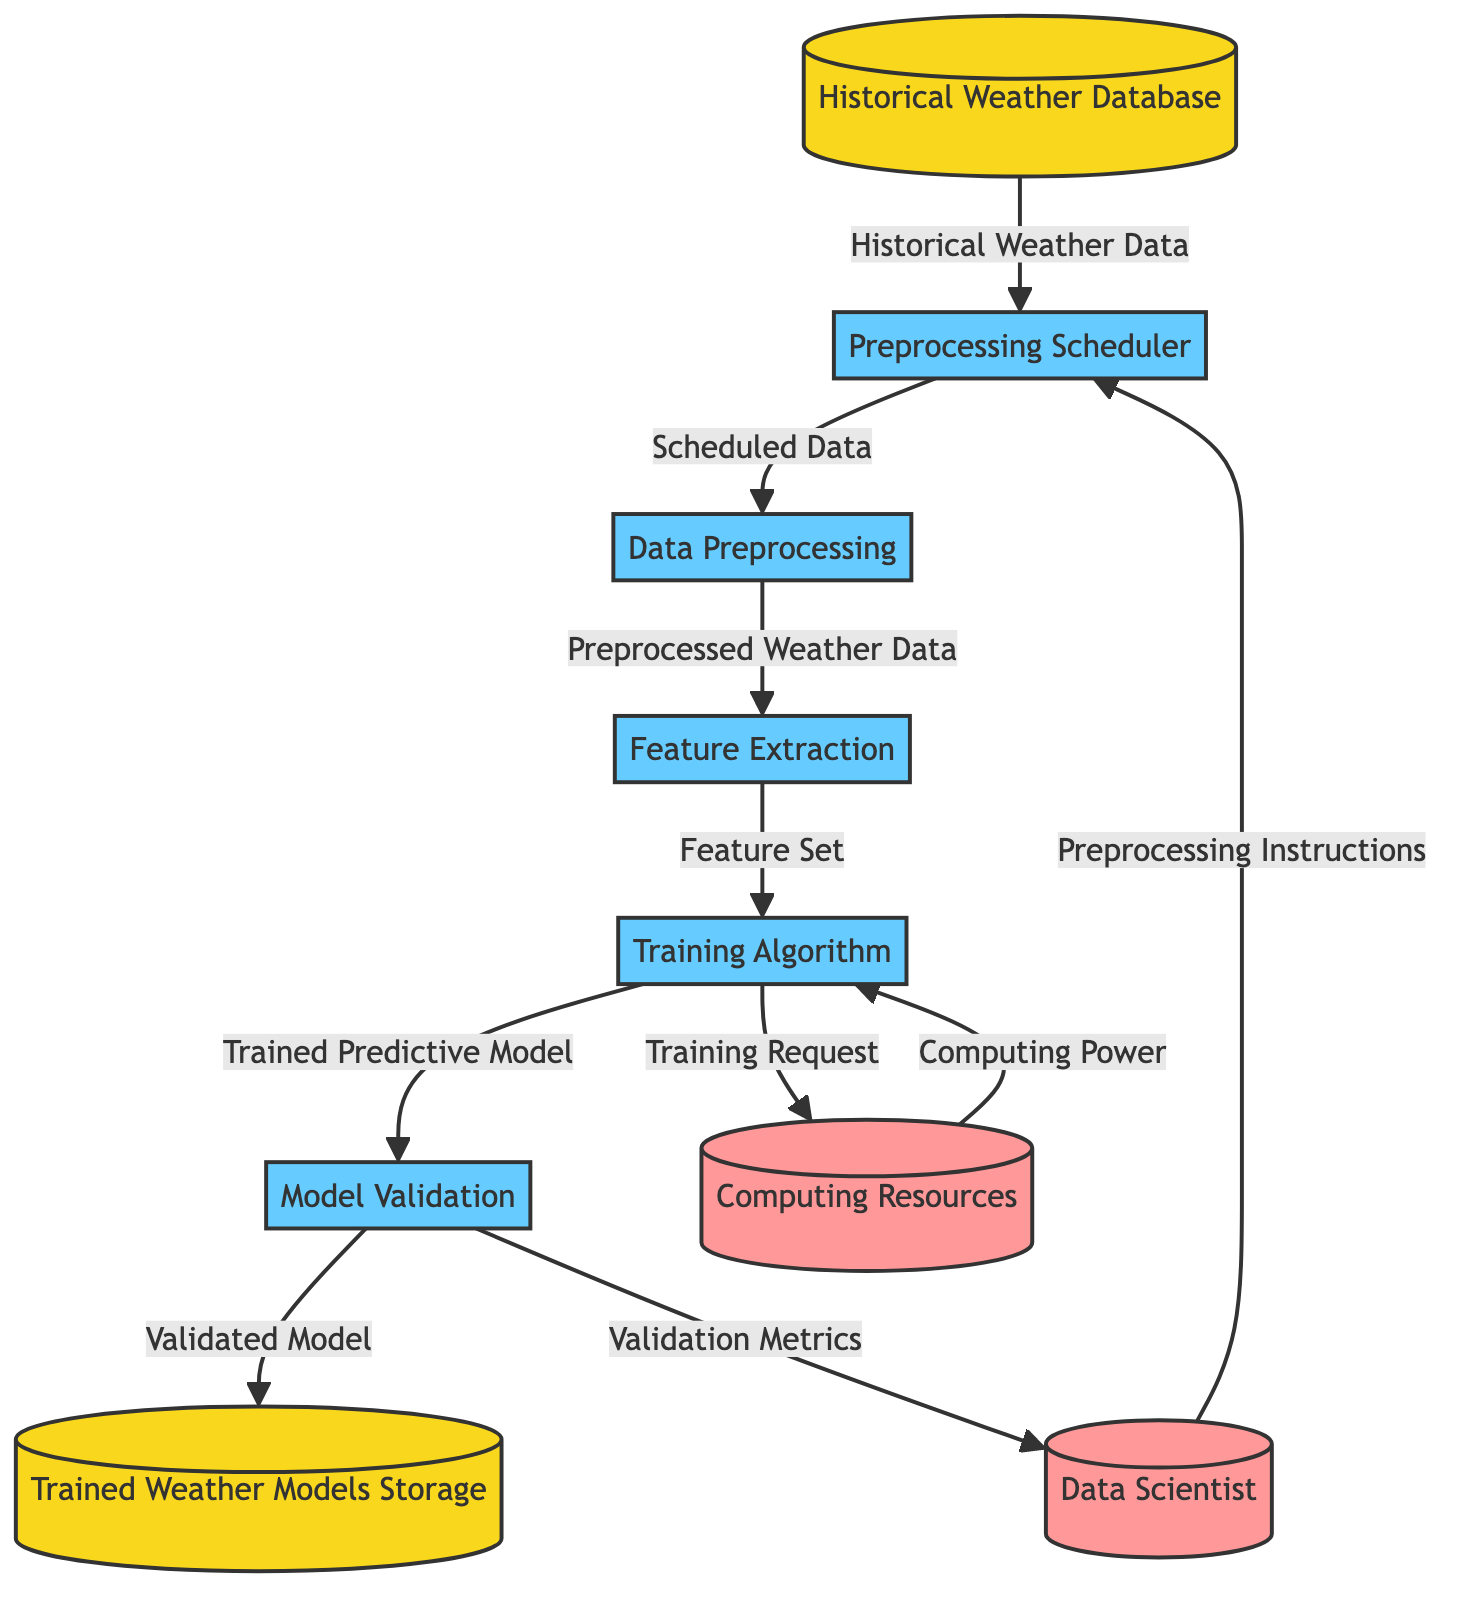What is the first data store in the pipeline? The first data store in the pipeline is the "Historical Weather Database," which is the source for historical weather data used in the training pipeline.
Answer: Historical Weather Database How many processes are in the diagram? There are five processes in the diagram: "Preprocessing Scheduler," "Data Preprocessing," "Feature Extraction," "Training Algorithm," and "Model Validation." Counting these processes leads to the total.
Answer: 5 What type of entity is "Data Scientist"? "Data Scientist" is classified as an "External Entity," which indicates it interacts with the processes but is not part of the system that processes data.
Answer: External Entity What is the output of "Model Validation"? The output of "Model Validation" is "Validated Model," which represents the result of validating the trained predictive models.
Answer: Validated Model Which process interacts with the "Computing Resources"? The "Training Algorithm" process interacts with "Computing Resources" via a training request that requires computing power to perform the training of the weather models.
Answer: Training Algorithm What data flow connects "Data Preprocessing" to "Feature Extraction"? The data flow connecting "Data Preprocessing" to "Feature Extraction" is labeled "Preprocessed Weather Data," indicating that this is the output of the preprocessing step and the input for feature extraction.
Answer: Preprocessed Weather Data Who provides the "Preprocessing Instructions"? The "Preprocessing Instructions" are provided by the "Data Scientist," indicating that they guide the preprocessing functions scheduled in the preprocessing scheduler.
Answer: Data Scientist What is stored in "Trained Weather Models Storage"? "Trained Weather Models Storage" contains "Validated Model," which is the output after passing the model validation process, ensuring that it meets the criteria for performance.
Answer: Validated Model What data flow goes from "Training Algorithm" to "Model Validation"? The data flow from "Training Algorithm" to "Model Validation" is called "Trained Predictive Model," which is the output of the training process sent for validation.
Answer: Trained Predictive Model What request does the "Training Algorithm" send to "Computing Resources"? The "Training Algorithm" sends a "Training Request" to "Computing Resources," signifying the need for computational power to carry out the training process.
Answer: Training Request 